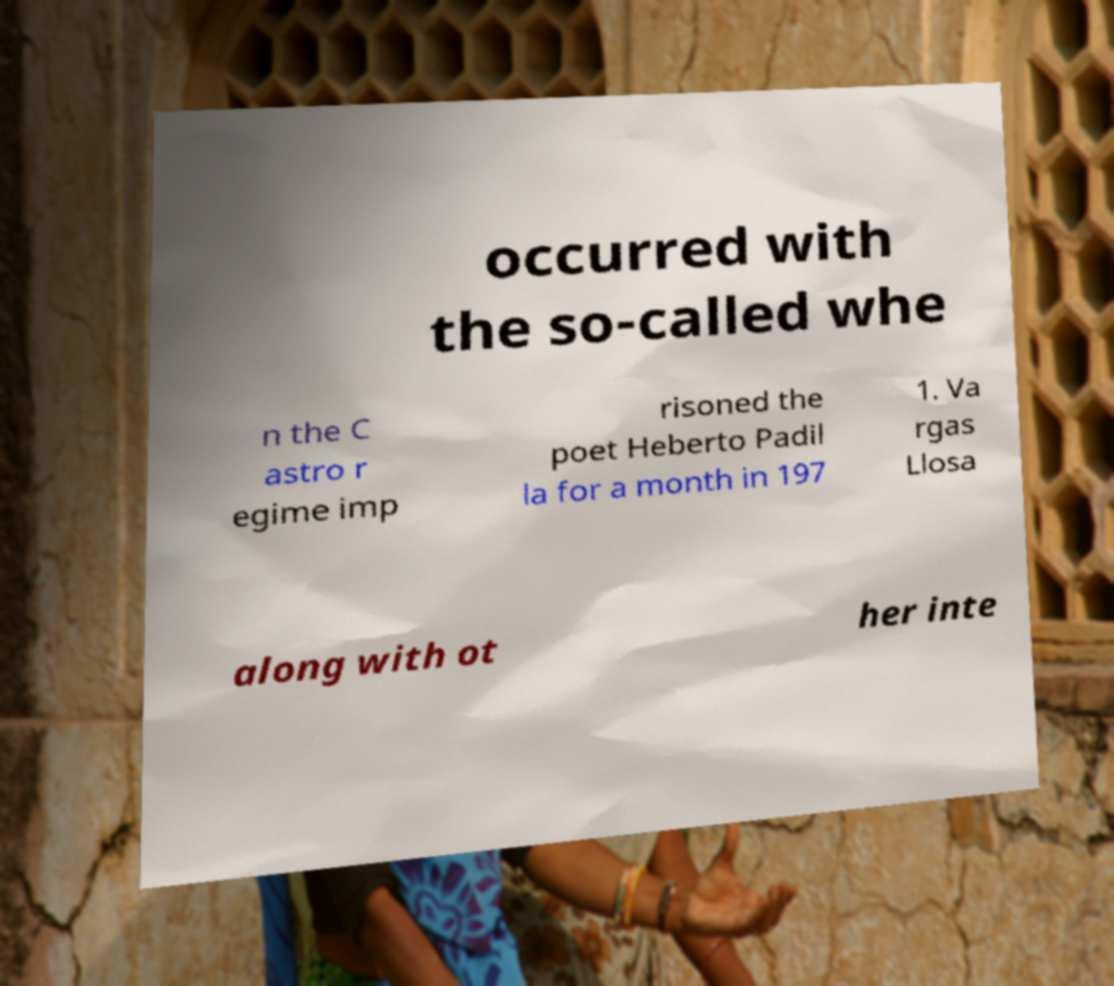What messages or text are displayed in this image? I need them in a readable, typed format. occurred with the so-called whe n the C astro r egime imp risoned the poet Heberto Padil la for a month in 197 1. Va rgas Llosa along with ot her inte 